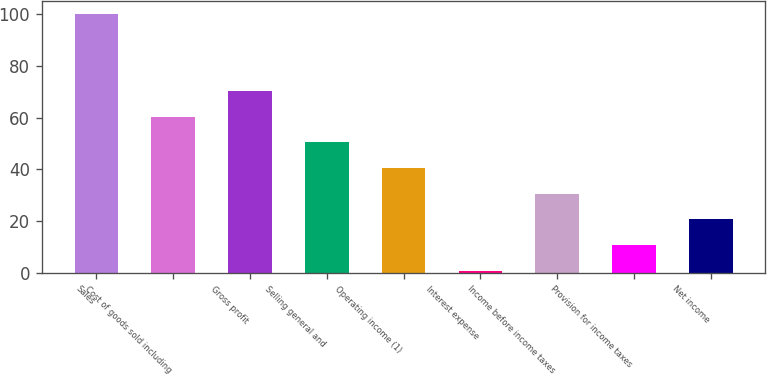Convert chart to OTSL. <chart><loc_0><loc_0><loc_500><loc_500><bar_chart><fcel>Sales<fcel>Cost of goods sold including<fcel>Gross profit<fcel>Selling general and<fcel>Operating income (1)<fcel>Interest expense<fcel>Income before income taxes<fcel>Provision for income taxes<fcel>Net income<nl><fcel>100<fcel>60.28<fcel>70.21<fcel>50.35<fcel>40.42<fcel>0.7<fcel>30.49<fcel>10.63<fcel>20.56<nl></chart> 